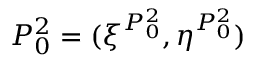Convert formula to latex. <formula><loc_0><loc_0><loc_500><loc_500>P _ { 0 } ^ { 2 } = ( \xi ^ { P _ { 0 } ^ { 2 } } , \eta ^ { P _ { 0 } ^ { 2 } } )</formula> 